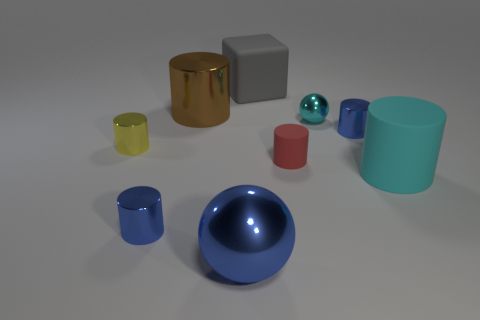Can you describe the colors of the objects present in the image? Certainly! The image displays objects with a variety of colors: there's a cyan sphere, a blue shiny sphere, a grey rubber block, a gold cylinder, a smaller yellow transparent cylinder, a red cylinder, and a larger teal cylinder. 